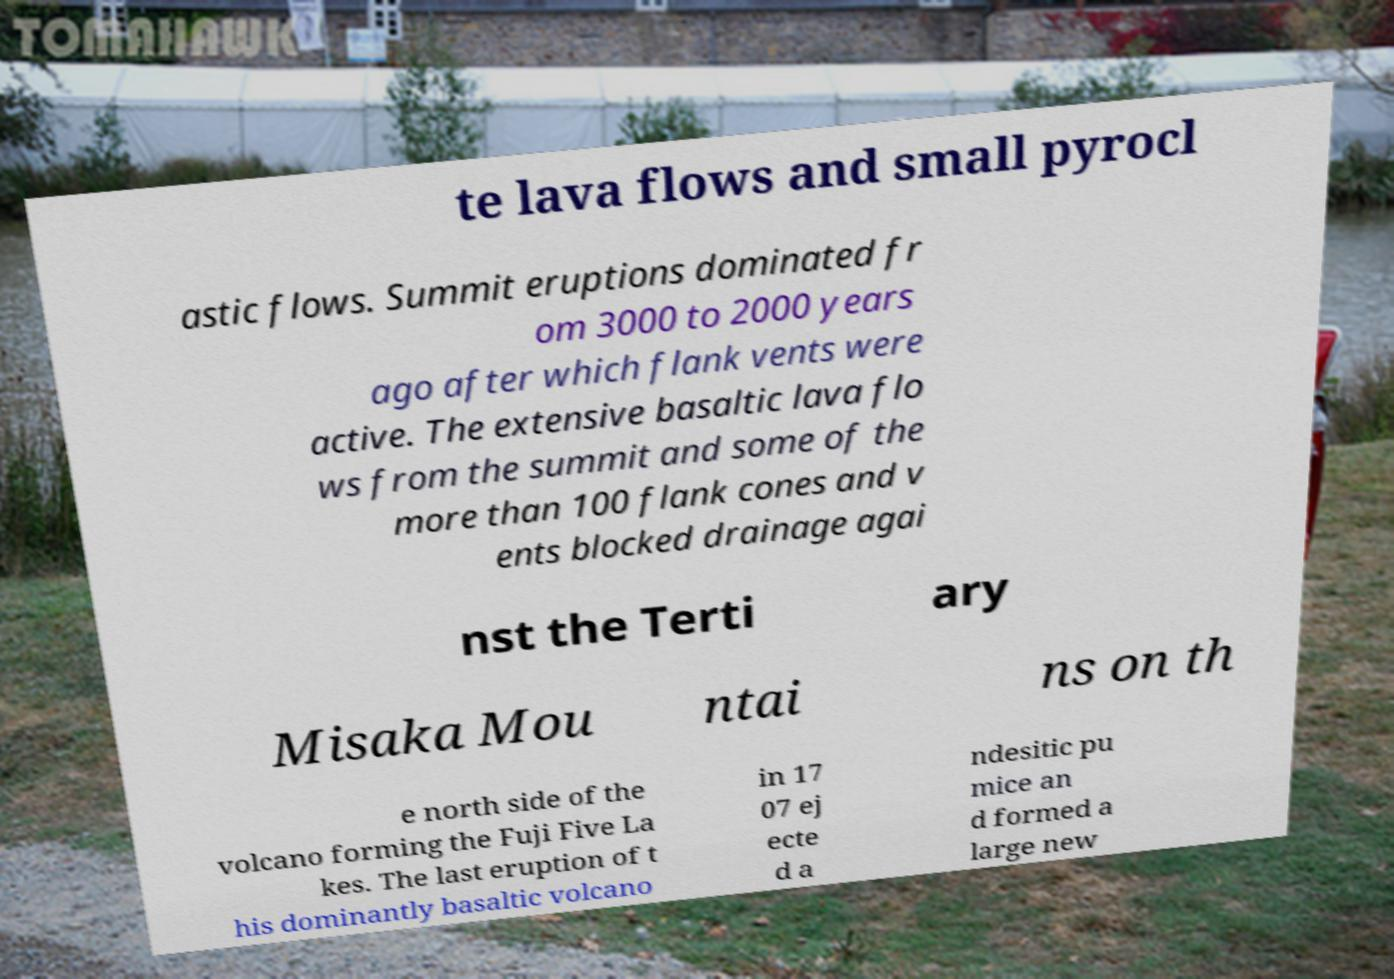Please read and relay the text visible in this image. What does it say? te lava flows and small pyrocl astic flows. Summit eruptions dominated fr om 3000 to 2000 years ago after which flank vents were active. The extensive basaltic lava flo ws from the summit and some of the more than 100 flank cones and v ents blocked drainage agai nst the Terti ary Misaka Mou ntai ns on th e north side of the volcano forming the Fuji Five La kes. The last eruption of t his dominantly basaltic volcano in 17 07 ej ecte d a ndesitic pu mice an d formed a large new 